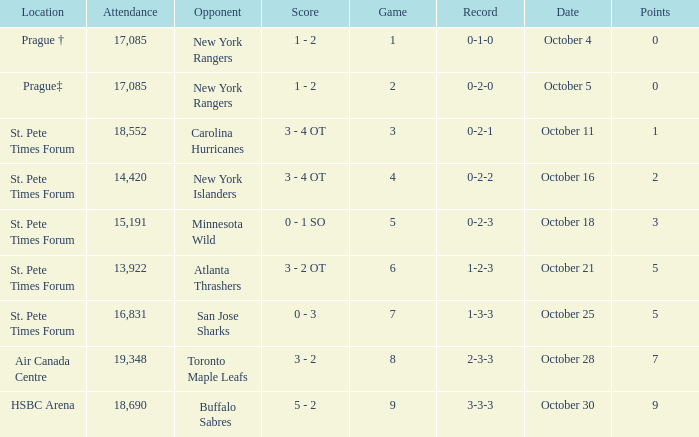What was the attendance when their record stood at 0-2-2? 14420.0. 